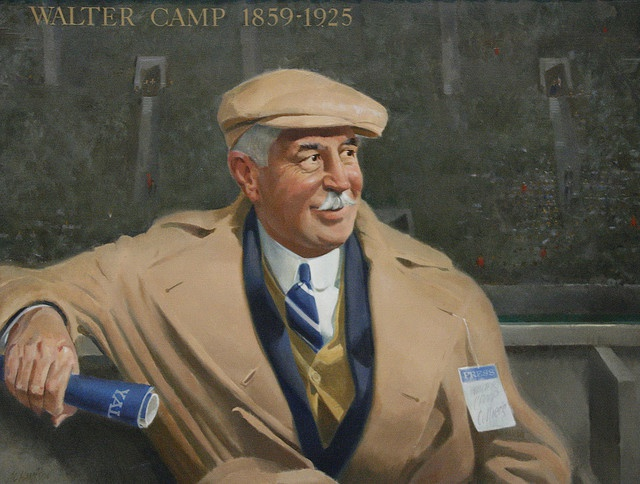Describe the objects in this image and their specific colors. I can see people in black, tan, and gray tones, bench in black and gray tones, book in black, darkblue, navy, blue, and darkgray tones, and tie in black, navy, darkblue, and darkgray tones in this image. 